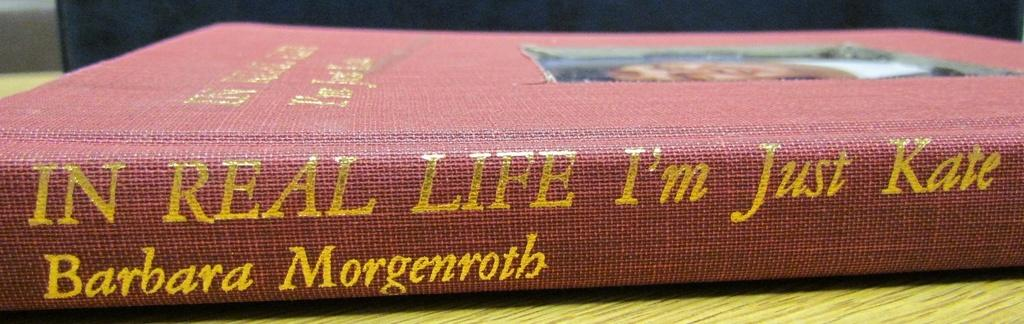<image>
Describe the image concisely. In real life I'm just Kate book by Barbara Morgenroth. 